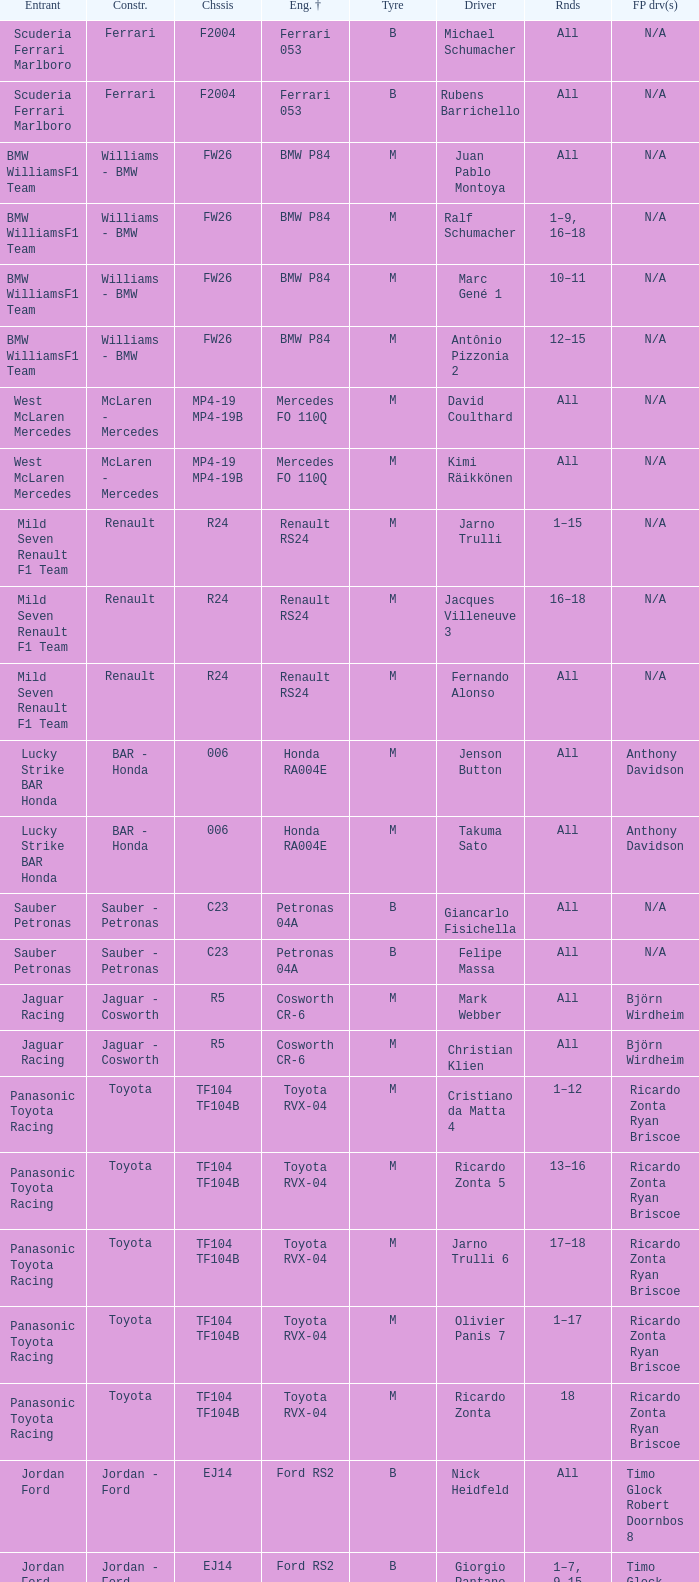What are the rounds for the B tyres and Ferrari 053 engine +? All, All. 